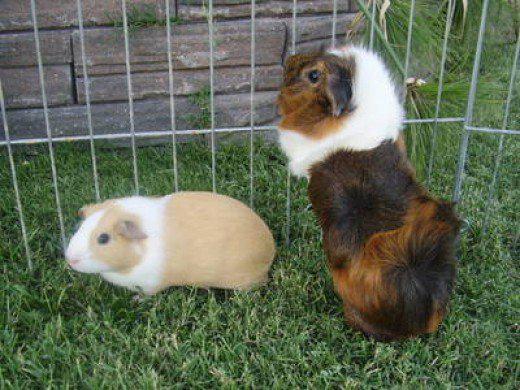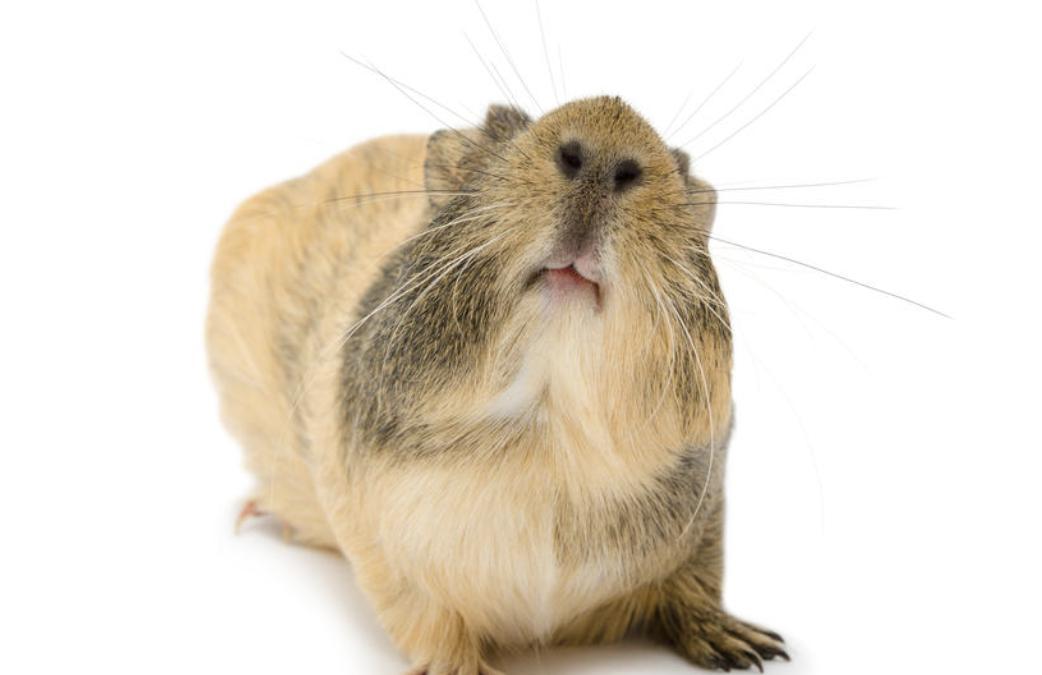The first image is the image on the left, the second image is the image on the right. Examine the images to the left and right. Is the description "Each image contains a single guinea pig, and the one on the right has all golden-orange fur." accurate? Answer yes or no. No. The first image is the image on the left, the second image is the image on the right. Examine the images to the left and right. Is the description "There are two hamsters lying down." accurate? Answer yes or no. No. 